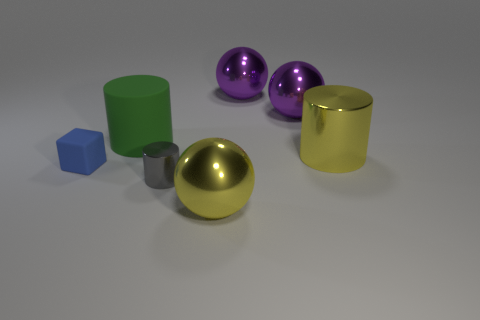What material is the tiny cube?
Provide a succinct answer. Rubber. Are there any tiny objects right of the large rubber object?
Ensure brevity in your answer.  Yes. Does the big matte object have the same shape as the small gray shiny thing?
Provide a succinct answer. Yes. How many other objects are the same size as the blue matte block?
Ensure brevity in your answer.  1. How many things are big metallic objects behind the blue object or gray shiny cylinders?
Ensure brevity in your answer.  4. The small block is what color?
Provide a short and direct response. Blue. There is a large object to the left of the small gray thing; what material is it?
Ensure brevity in your answer.  Rubber. There is a green object; is its shape the same as the tiny thing that is to the right of the big green matte object?
Provide a succinct answer. Yes. Is the number of large green things greater than the number of large purple objects?
Your response must be concise. No. Is there any other thing that has the same color as the large shiny cylinder?
Make the answer very short. Yes. 